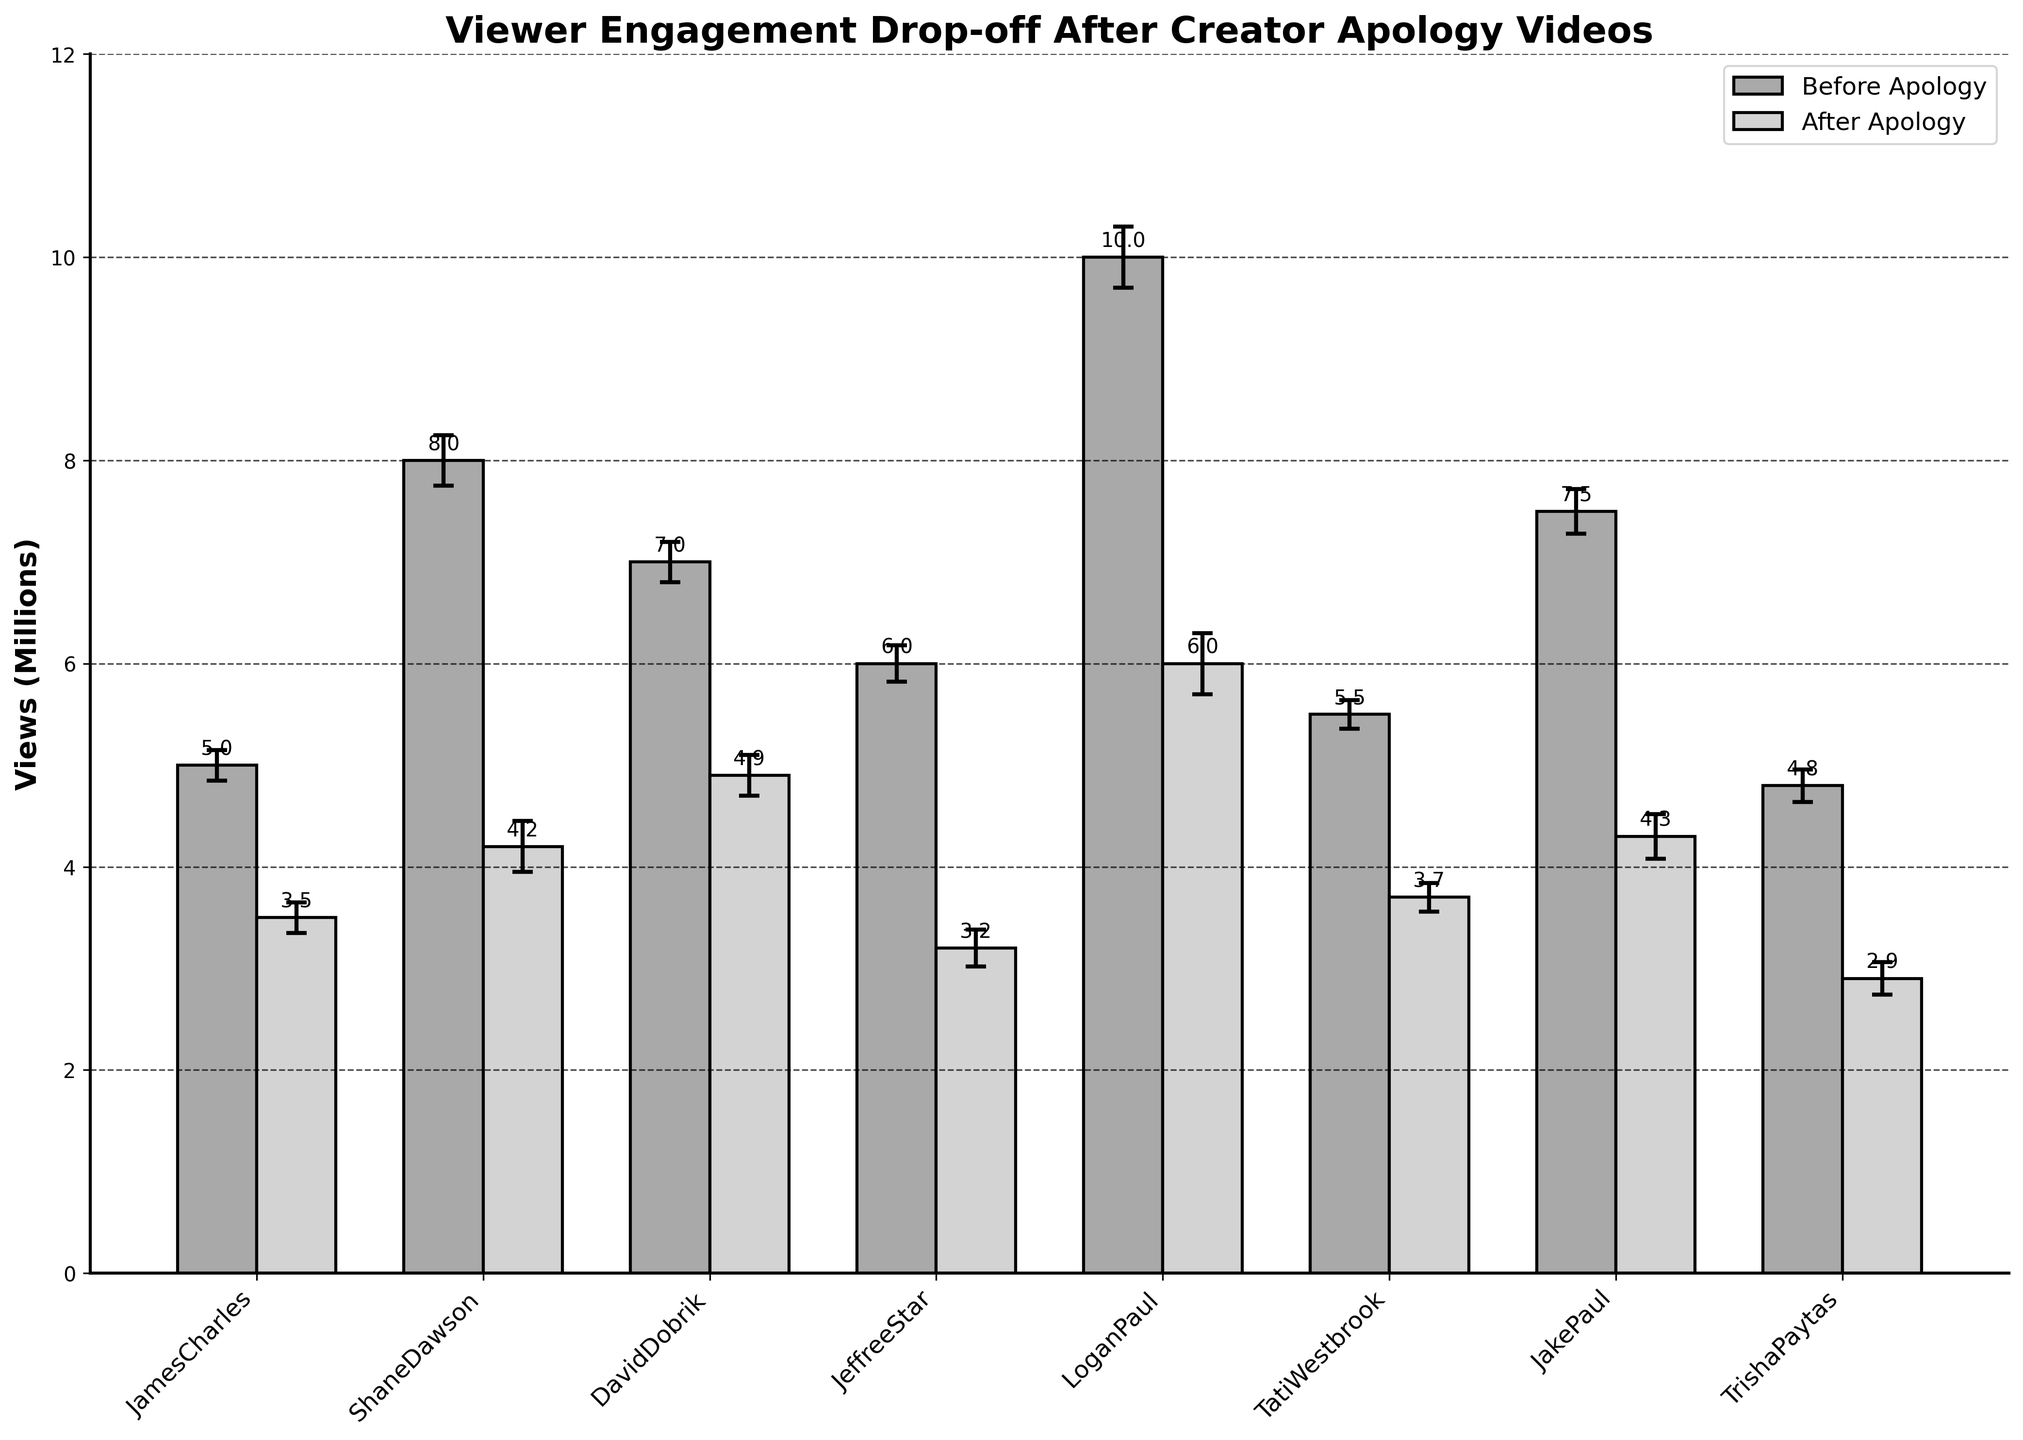What's the title of the chart? The title of the chart is displayed at the top and reads "Viewer Engagement Drop-off After Creator Apology Videos"
Answer: Viewer Engagement Drop-off After Creator Apology Videos What is the range of the y-axis? The y-axis is labeled "Views (Millions)". It starts at 0 and goes up to 12, extending high enough to cover the maximum views with an additional buffer.
Answer: 0 to 12 million Which content creator had the highest number of views before the apology? Looking at the heights of the bars representing "Before Apology" views, Logan Paul had the highest bar, indicating that he had the most views before the apology.
Answer: Logan Paul Which content creator experienced the largest drop in views after the apology? To determine the largest drop, compare the heights of the "Before Apology" and "After Apology" bars for each creator. Logan Paul's drop is the largest visually.
Answer: Logan Paul For Jeffree Star, how many views did he lose after the apology? Jeffree Star had about 6 million views before the apology and about 3.2 million views after the apology. Subtracting these gives 6 - 3.2 = 2.8 million views lost.
Answer: 2.8 million How does the standard deviation of views before and after the apology videos compare across the creators? The standard deviation for each creator is shown as error bars. These vertical lines with caps appear to be relatively similar in size across the creators, with no distinctive differences.
Answer: Relatively similar for all creators Which two content creators have the closest number of views after the apology? By comparing the "After Apology" bars, Tati Westbrook (3.7 million) and James Charles (3.5 million) have close values.
Answer: Tati Westbrook and James Charles On average, how many views do the creators have after the apology videos? Sum the "After Apology" views: 3.5 + 4.2 + 4.9 + 3.2 + 6 + 3.7 + 4.3 + 2.9 = 32.7 million. Divide by 8 (number of creators): 32.7 / 8 = 4.0875 million views.
Answer: 4.09 million Which content creator has the smallest standard deviation of views? The error bars indicate the standard deviation. Tati Westbrook has the smallest error bars, representing the smallest standard deviation.
Answer: Tati Westbrook By what percentage did James Charles' views decrease after the apology? James Charles had 5 million views before and 3.5 million after. The difference is 5 - 3.5 = 1.5 million. The percentage drop is (1.5 / 5) * 100 = 30%.
Answer: 30% 